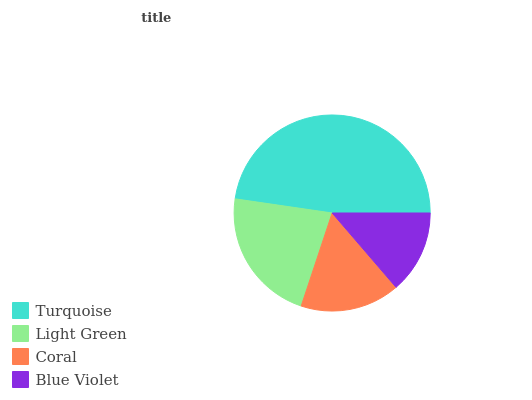Is Blue Violet the minimum?
Answer yes or no. Yes. Is Turquoise the maximum?
Answer yes or no. Yes. Is Light Green the minimum?
Answer yes or no. No. Is Light Green the maximum?
Answer yes or no. No. Is Turquoise greater than Light Green?
Answer yes or no. Yes. Is Light Green less than Turquoise?
Answer yes or no. Yes. Is Light Green greater than Turquoise?
Answer yes or no. No. Is Turquoise less than Light Green?
Answer yes or no. No. Is Light Green the high median?
Answer yes or no. Yes. Is Coral the low median?
Answer yes or no. Yes. Is Turquoise the high median?
Answer yes or no. No. Is Turquoise the low median?
Answer yes or no. No. 